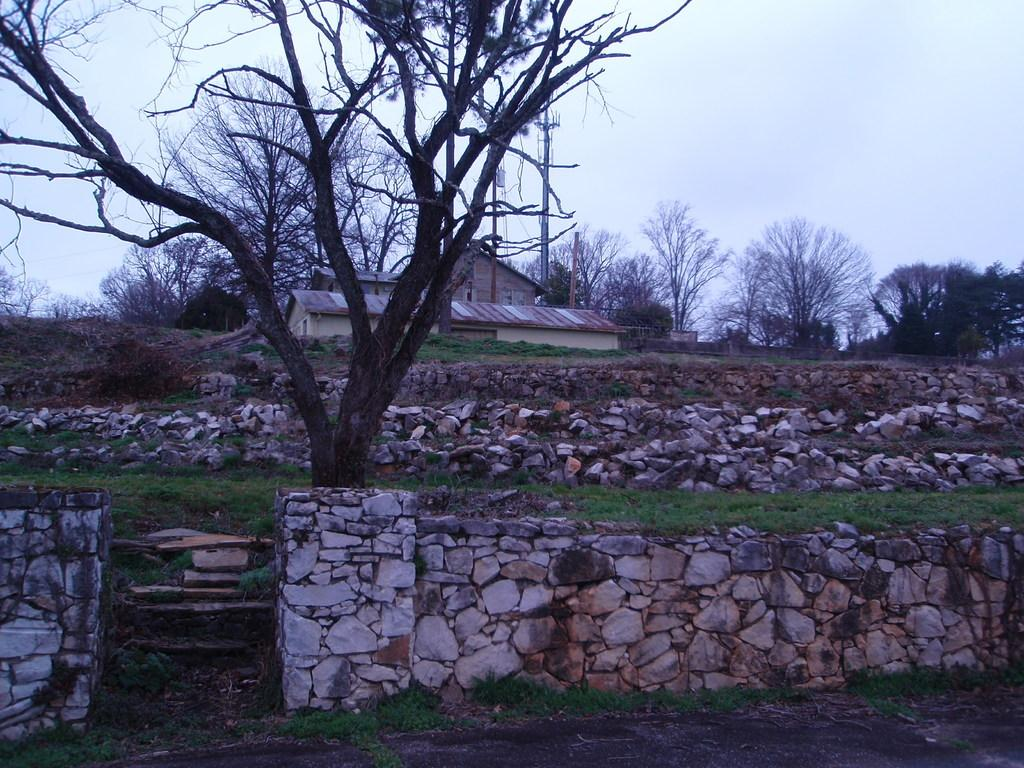What type of natural elements can be seen in the image? There are trees in the image. What type of structures are present in the image? There are rock walls and shelter houses in the image. What else can be seen in the image besides trees and structures? There are poles in the image. What is visible at the top of the image? The sky is visible at the top of the image. How many ducks are sitting on the bottle in the image? There are no ducks or bottles present in the image. What is the cause of death for the person in the image? There is no person or indication of death in the image. 